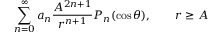<formula> <loc_0><loc_0><loc_500><loc_500>\sum _ { n = 0 } ^ { \infty } a _ { n } { \frac { A ^ { 2 n + 1 } } { r ^ { n + 1 } } } P _ { n } ( \cos \theta ) , \quad r \geq A</formula> 